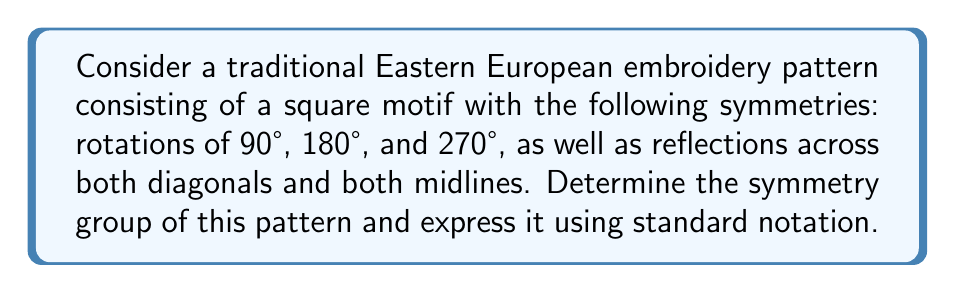Help me with this question. Let's approach this step-by-step:

1) First, we need to identify all the symmetries of the pattern:
   - Identity (no change)
   - Rotations: 90°, 180°, 270°
   - Reflections: 2 diagonal, 2 midline

2) This gives us a total of 8 symmetries.

3) The rotations form a cyclic subgroup of order 4, which we can denote as $C_4$.

4) The reflections, combined with the identity and 180° rotation, form a subgroup isomorphic to $D_2$ (the dihedral group of order 4).

5) The combination of these symmetries forms a group that is isomorphic to the dihedral group of order 8, denoted as $D_4$.

6) In group theory notation, we can express this as:

   $$D_4 = \langle r, s \mid r^4 = s^2 = 1, srs = r^{-1} \rangle$$

   Where $r$ represents a 90° rotation and $s$ represents a reflection.

7) This group is also isomorphic to the symmetries of a square, which aligns with the square motif of the embroidery pattern.

8) In crystallographic notation, this symmetry group is denoted as 4mm.

Therefore, the symmetry group of this traditional Eastern European embroidery pattern is the dihedral group $D_4$, also known as the symmetry group of a square.
Answer: $D_4$ or 4mm 